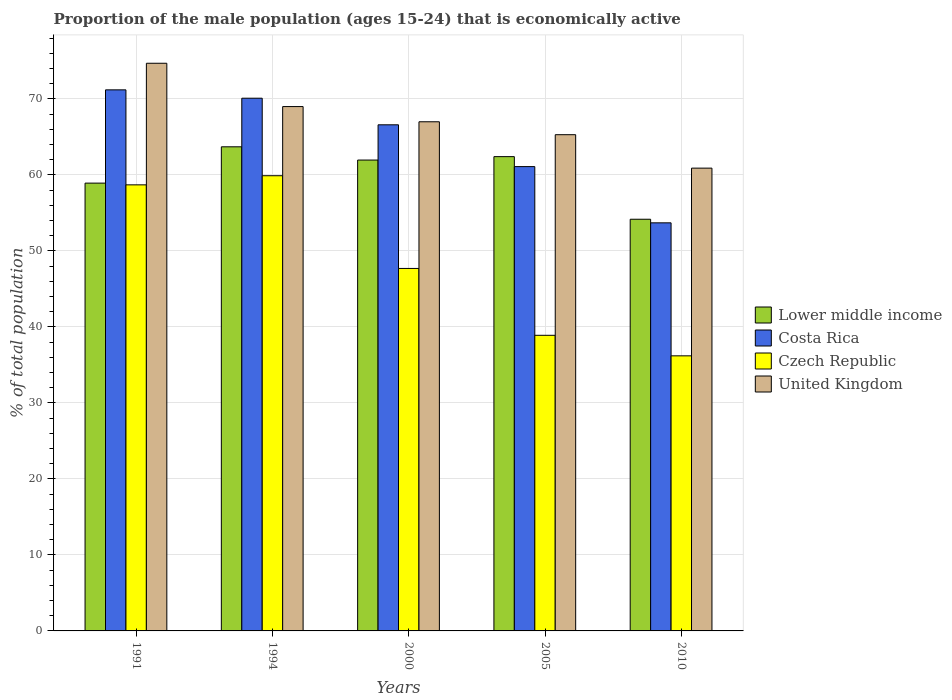How many different coloured bars are there?
Provide a short and direct response. 4. How many groups of bars are there?
Make the answer very short. 5. Are the number of bars per tick equal to the number of legend labels?
Offer a very short reply. Yes. Are the number of bars on each tick of the X-axis equal?
Your answer should be very brief. Yes. How many bars are there on the 3rd tick from the left?
Provide a short and direct response. 4. What is the label of the 4th group of bars from the left?
Ensure brevity in your answer.  2005. In how many cases, is the number of bars for a given year not equal to the number of legend labels?
Make the answer very short. 0. What is the proportion of the male population that is economically active in Lower middle income in 1991?
Your answer should be very brief. 58.93. Across all years, what is the maximum proportion of the male population that is economically active in Lower middle income?
Keep it short and to the point. 63.71. Across all years, what is the minimum proportion of the male population that is economically active in Costa Rica?
Offer a terse response. 53.7. In which year was the proportion of the male population that is economically active in Lower middle income maximum?
Ensure brevity in your answer.  1994. What is the total proportion of the male population that is economically active in Czech Republic in the graph?
Offer a very short reply. 241.4. What is the difference between the proportion of the male population that is economically active in Lower middle income in 1994 and that in 2005?
Give a very brief answer. 1.29. What is the difference between the proportion of the male population that is economically active in Lower middle income in 2005 and the proportion of the male population that is economically active in Costa Rica in 1991?
Keep it short and to the point. -8.79. What is the average proportion of the male population that is economically active in Czech Republic per year?
Give a very brief answer. 48.28. In the year 2005, what is the difference between the proportion of the male population that is economically active in Lower middle income and proportion of the male population that is economically active in United Kingdom?
Give a very brief answer. -2.89. In how many years, is the proportion of the male population that is economically active in United Kingdom greater than 54 %?
Provide a short and direct response. 5. What is the ratio of the proportion of the male population that is economically active in Costa Rica in 1991 to that in 2010?
Your answer should be very brief. 1.33. What is the difference between the highest and the second highest proportion of the male population that is economically active in Czech Republic?
Your answer should be compact. 1.2. What is the difference between the highest and the lowest proportion of the male population that is economically active in Costa Rica?
Give a very brief answer. 17.5. In how many years, is the proportion of the male population that is economically active in Czech Republic greater than the average proportion of the male population that is economically active in Czech Republic taken over all years?
Offer a terse response. 2. Is it the case that in every year, the sum of the proportion of the male population that is economically active in Costa Rica and proportion of the male population that is economically active in Lower middle income is greater than the sum of proportion of the male population that is economically active in United Kingdom and proportion of the male population that is economically active in Czech Republic?
Ensure brevity in your answer.  No. What does the 2nd bar from the left in 2000 represents?
Provide a short and direct response. Costa Rica. What does the 1st bar from the right in 2000 represents?
Your response must be concise. United Kingdom. How many bars are there?
Provide a short and direct response. 20. Are all the bars in the graph horizontal?
Offer a very short reply. No. How many years are there in the graph?
Keep it short and to the point. 5. What is the difference between two consecutive major ticks on the Y-axis?
Your answer should be compact. 10. Does the graph contain grids?
Your answer should be compact. Yes. How are the legend labels stacked?
Provide a succinct answer. Vertical. What is the title of the graph?
Provide a succinct answer. Proportion of the male population (ages 15-24) that is economically active. What is the label or title of the X-axis?
Make the answer very short. Years. What is the label or title of the Y-axis?
Provide a succinct answer. % of total population. What is the % of total population of Lower middle income in 1991?
Offer a terse response. 58.93. What is the % of total population in Costa Rica in 1991?
Keep it short and to the point. 71.2. What is the % of total population in Czech Republic in 1991?
Keep it short and to the point. 58.7. What is the % of total population in United Kingdom in 1991?
Offer a terse response. 74.7. What is the % of total population in Lower middle income in 1994?
Offer a very short reply. 63.71. What is the % of total population in Costa Rica in 1994?
Make the answer very short. 70.1. What is the % of total population in Czech Republic in 1994?
Offer a terse response. 59.9. What is the % of total population in United Kingdom in 1994?
Offer a very short reply. 69. What is the % of total population in Lower middle income in 2000?
Make the answer very short. 61.96. What is the % of total population in Costa Rica in 2000?
Offer a very short reply. 66.6. What is the % of total population in Czech Republic in 2000?
Provide a short and direct response. 47.7. What is the % of total population in Lower middle income in 2005?
Offer a terse response. 62.41. What is the % of total population of Costa Rica in 2005?
Your response must be concise. 61.1. What is the % of total population in Czech Republic in 2005?
Your answer should be very brief. 38.9. What is the % of total population in United Kingdom in 2005?
Make the answer very short. 65.3. What is the % of total population of Lower middle income in 2010?
Keep it short and to the point. 54.17. What is the % of total population in Costa Rica in 2010?
Offer a terse response. 53.7. What is the % of total population in Czech Republic in 2010?
Your answer should be compact. 36.2. What is the % of total population of United Kingdom in 2010?
Keep it short and to the point. 60.9. Across all years, what is the maximum % of total population in Lower middle income?
Provide a short and direct response. 63.71. Across all years, what is the maximum % of total population in Costa Rica?
Your response must be concise. 71.2. Across all years, what is the maximum % of total population of Czech Republic?
Provide a succinct answer. 59.9. Across all years, what is the maximum % of total population of United Kingdom?
Your answer should be compact. 74.7. Across all years, what is the minimum % of total population of Lower middle income?
Give a very brief answer. 54.17. Across all years, what is the minimum % of total population in Costa Rica?
Your answer should be very brief. 53.7. Across all years, what is the minimum % of total population in Czech Republic?
Give a very brief answer. 36.2. Across all years, what is the minimum % of total population in United Kingdom?
Your response must be concise. 60.9. What is the total % of total population in Lower middle income in the graph?
Your answer should be very brief. 301.18. What is the total % of total population in Costa Rica in the graph?
Give a very brief answer. 322.7. What is the total % of total population in Czech Republic in the graph?
Offer a very short reply. 241.4. What is the total % of total population of United Kingdom in the graph?
Your answer should be compact. 336.9. What is the difference between the % of total population of Lower middle income in 1991 and that in 1994?
Provide a succinct answer. -4.78. What is the difference between the % of total population in Costa Rica in 1991 and that in 1994?
Ensure brevity in your answer.  1.1. What is the difference between the % of total population of Czech Republic in 1991 and that in 1994?
Make the answer very short. -1.2. What is the difference between the % of total population in United Kingdom in 1991 and that in 1994?
Your answer should be very brief. 5.7. What is the difference between the % of total population in Lower middle income in 1991 and that in 2000?
Give a very brief answer. -3.04. What is the difference between the % of total population in Costa Rica in 1991 and that in 2000?
Offer a terse response. 4.6. What is the difference between the % of total population of Czech Republic in 1991 and that in 2000?
Make the answer very short. 11. What is the difference between the % of total population in United Kingdom in 1991 and that in 2000?
Your answer should be compact. 7.7. What is the difference between the % of total population of Lower middle income in 1991 and that in 2005?
Provide a succinct answer. -3.49. What is the difference between the % of total population in Czech Republic in 1991 and that in 2005?
Offer a terse response. 19.8. What is the difference between the % of total population in Lower middle income in 1991 and that in 2010?
Your answer should be very brief. 4.75. What is the difference between the % of total population of Czech Republic in 1991 and that in 2010?
Provide a short and direct response. 22.5. What is the difference between the % of total population in United Kingdom in 1991 and that in 2010?
Provide a succinct answer. 13.8. What is the difference between the % of total population of Lower middle income in 1994 and that in 2000?
Your response must be concise. 1.74. What is the difference between the % of total population of United Kingdom in 1994 and that in 2000?
Make the answer very short. 2. What is the difference between the % of total population of Lower middle income in 1994 and that in 2005?
Offer a very short reply. 1.29. What is the difference between the % of total population of Lower middle income in 1994 and that in 2010?
Ensure brevity in your answer.  9.53. What is the difference between the % of total population of Costa Rica in 1994 and that in 2010?
Your response must be concise. 16.4. What is the difference between the % of total population of Czech Republic in 1994 and that in 2010?
Offer a terse response. 23.7. What is the difference between the % of total population of United Kingdom in 1994 and that in 2010?
Your answer should be very brief. 8.1. What is the difference between the % of total population in Lower middle income in 2000 and that in 2005?
Give a very brief answer. -0.45. What is the difference between the % of total population in United Kingdom in 2000 and that in 2005?
Offer a terse response. 1.7. What is the difference between the % of total population of Lower middle income in 2000 and that in 2010?
Offer a terse response. 7.79. What is the difference between the % of total population in Costa Rica in 2000 and that in 2010?
Make the answer very short. 12.9. What is the difference between the % of total population of Lower middle income in 2005 and that in 2010?
Provide a succinct answer. 8.24. What is the difference between the % of total population of Costa Rica in 2005 and that in 2010?
Make the answer very short. 7.4. What is the difference between the % of total population in Czech Republic in 2005 and that in 2010?
Provide a short and direct response. 2.7. What is the difference between the % of total population of United Kingdom in 2005 and that in 2010?
Ensure brevity in your answer.  4.4. What is the difference between the % of total population in Lower middle income in 1991 and the % of total population in Costa Rica in 1994?
Ensure brevity in your answer.  -11.17. What is the difference between the % of total population in Lower middle income in 1991 and the % of total population in Czech Republic in 1994?
Offer a very short reply. -0.97. What is the difference between the % of total population of Lower middle income in 1991 and the % of total population of United Kingdom in 1994?
Make the answer very short. -10.07. What is the difference between the % of total population of Costa Rica in 1991 and the % of total population of Czech Republic in 1994?
Offer a very short reply. 11.3. What is the difference between the % of total population in Costa Rica in 1991 and the % of total population in United Kingdom in 1994?
Give a very brief answer. 2.2. What is the difference between the % of total population of Czech Republic in 1991 and the % of total population of United Kingdom in 1994?
Provide a short and direct response. -10.3. What is the difference between the % of total population of Lower middle income in 1991 and the % of total population of Costa Rica in 2000?
Keep it short and to the point. -7.67. What is the difference between the % of total population in Lower middle income in 1991 and the % of total population in Czech Republic in 2000?
Ensure brevity in your answer.  11.23. What is the difference between the % of total population of Lower middle income in 1991 and the % of total population of United Kingdom in 2000?
Offer a terse response. -8.07. What is the difference between the % of total population in Costa Rica in 1991 and the % of total population in Czech Republic in 2000?
Provide a short and direct response. 23.5. What is the difference between the % of total population of Costa Rica in 1991 and the % of total population of United Kingdom in 2000?
Make the answer very short. 4.2. What is the difference between the % of total population of Lower middle income in 1991 and the % of total population of Costa Rica in 2005?
Provide a short and direct response. -2.17. What is the difference between the % of total population in Lower middle income in 1991 and the % of total population in Czech Republic in 2005?
Give a very brief answer. 20.03. What is the difference between the % of total population in Lower middle income in 1991 and the % of total population in United Kingdom in 2005?
Provide a short and direct response. -6.37. What is the difference between the % of total population of Costa Rica in 1991 and the % of total population of Czech Republic in 2005?
Provide a succinct answer. 32.3. What is the difference between the % of total population in Czech Republic in 1991 and the % of total population in United Kingdom in 2005?
Keep it short and to the point. -6.6. What is the difference between the % of total population of Lower middle income in 1991 and the % of total population of Costa Rica in 2010?
Offer a very short reply. 5.23. What is the difference between the % of total population of Lower middle income in 1991 and the % of total population of Czech Republic in 2010?
Provide a succinct answer. 22.73. What is the difference between the % of total population of Lower middle income in 1991 and the % of total population of United Kingdom in 2010?
Keep it short and to the point. -1.97. What is the difference between the % of total population of Lower middle income in 1994 and the % of total population of Costa Rica in 2000?
Your answer should be compact. -2.89. What is the difference between the % of total population in Lower middle income in 1994 and the % of total population in Czech Republic in 2000?
Keep it short and to the point. 16.01. What is the difference between the % of total population in Lower middle income in 1994 and the % of total population in United Kingdom in 2000?
Offer a terse response. -3.29. What is the difference between the % of total population of Costa Rica in 1994 and the % of total population of Czech Republic in 2000?
Offer a terse response. 22.4. What is the difference between the % of total population of Czech Republic in 1994 and the % of total population of United Kingdom in 2000?
Your response must be concise. -7.1. What is the difference between the % of total population of Lower middle income in 1994 and the % of total population of Costa Rica in 2005?
Provide a short and direct response. 2.61. What is the difference between the % of total population of Lower middle income in 1994 and the % of total population of Czech Republic in 2005?
Give a very brief answer. 24.81. What is the difference between the % of total population in Lower middle income in 1994 and the % of total population in United Kingdom in 2005?
Give a very brief answer. -1.59. What is the difference between the % of total population in Costa Rica in 1994 and the % of total population in Czech Republic in 2005?
Your response must be concise. 31.2. What is the difference between the % of total population of Lower middle income in 1994 and the % of total population of Costa Rica in 2010?
Offer a terse response. 10.01. What is the difference between the % of total population in Lower middle income in 1994 and the % of total population in Czech Republic in 2010?
Offer a terse response. 27.51. What is the difference between the % of total population of Lower middle income in 1994 and the % of total population of United Kingdom in 2010?
Provide a succinct answer. 2.81. What is the difference between the % of total population of Costa Rica in 1994 and the % of total population of Czech Republic in 2010?
Give a very brief answer. 33.9. What is the difference between the % of total population in Costa Rica in 1994 and the % of total population in United Kingdom in 2010?
Ensure brevity in your answer.  9.2. What is the difference between the % of total population of Czech Republic in 1994 and the % of total population of United Kingdom in 2010?
Your response must be concise. -1. What is the difference between the % of total population of Lower middle income in 2000 and the % of total population of Costa Rica in 2005?
Your response must be concise. 0.86. What is the difference between the % of total population of Lower middle income in 2000 and the % of total population of Czech Republic in 2005?
Make the answer very short. 23.06. What is the difference between the % of total population in Lower middle income in 2000 and the % of total population in United Kingdom in 2005?
Ensure brevity in your answer.  -3.34. What is the difference between the % of total population of Costa Rica in 2000 and the % of total population of Czech Republic in 2005?
Give a very brief answer. 27.7. What is the difference between the % of total population of Czech Republic in 2000 and the % of total population of United Kingdom in 2005?
Your answer should be compact. -17.6. What is the difference between the % of total population in Lower middle income in 2000 and the % of total population in Costa Rica in 2010?
Your answer should be compact. 8.26. What is the difference between the % of total population of Lower middle income in 2000 and the % of total population of Czech Republic in 2010?
Provide a succinct answer. 25.76. What is the difference between the % of total population in Lower middle income in 2000 and the % of total population in United Kingdom in 2010?
Keep it short and to the point. 1.06. What is the difference between the % of total population in Costa Rica in 2000 and the % of total population in Czech Republic in 2010?
Make the answer very short. 30.4. What is the difference between the % of total population in Costa Rica in 2000 and the % of total population in United Kingdom in 2010?
Offer a terse response. 5.7. What is the difference between the % of total population in Lower middle income in 2005 and the % of total population in Costa Rica in 2010?
Your answer should be compact. 8.71. What is the difference between the % of total population in Lower middle income in 2005 and the % of total population in Czech Republic in 2010?
Ensure brevity in your answer.  26.21. What is the difference between the % of total population in Lower middle income in 2005 and the % of total population in United Kingdom in 2010?
Your response must be concise. 1.51. What is the difference between the % of total population in Costa Rica in 2005 and the % of total population in Czech Republic in 2010?
Keep it short and to the point. 24.9. What is the difference between the % of total population in Costa Rica in 2005 and the % of total population in United Kingdom in 2010?
Ensure brevity in your answer.  0.2. What is the average % of total population of Lower middle income per year?
Ensure brevity in your answer.  60.24. What is the average % of total population of Costa Rica per year?
Offer a terse response. 64.54. What is the average % of total population in Czech Republic per year?
Offer a very short reply. 48.28. What is the average % of total population of United Kingdom per year?
Give a very brief answer. 67.38. In the year 1991, what is the difference between the % of total population in Lower middle income and % of total population in Costa Rica?
Provide a short and direct response. -12.27. In the year 1991, what is the difference between the % of total population in Lower middle income and % of total population in Czech Republic?
Ensure brevity in your answer.  0.23. In the year 1991, what is the difference between the % of total population in Lower middle income and % of total population in United Kingdom?
Offer a very short reply. -15.77. In the year 1991, what is the difference between the % of total population in Czech Republic and % of total population in United Kingdom?
Offer a terse response. -16. In the year 1994, what is the difference between the % of total population in Lower middle income and % of total population in Costa Rica?
Your answer should be compact. -6.39. In the year 1994, what is the difference between the % of total population in Lower middle income and % of total population in Czech Republic?
Give a very brief answer. 3.81. In the year 1994, what is the difference between the % of total population of Lower middle income and % of total population of United Kingdom?
Give a very brief answer. -5.29. In the year 1994, what is the difference between the % of total population of Costa Rica and % of total population of Czech Republic?
Your response must be concise. 10.2. In the year 1994, what is the difference between the % of total population in Czech Republic and % of total population in United Kingdom?
Make the answer very short. -9.1. In the year 2000, what is the difference between the % of total population of Lower middle income and % of total population of Costa Rica?
Your answer should be very brief. -4.64. In the year 2000, what is the difference between the % of total population in Lower middle income and % of total population in Czech Republic?
Offer a terse response. 14.26. In the year 2000, what is the difference between the % of total population of Lower middle income and % of total population of United Kingdom?
Offer a very short reply. -5.04. In the year 2000, what is the difference between the % of total population in Costa Rica and % of total population in United Kingdom?
Provide a short and direct response. -0.4. In the year 2000, what is the difference between the % of total population in Czech Republic and % of total population in United Kingdom?
Provide a succinct answer. -19.3. In the year 2005, what is the difference between the % of total population in Lower middle income and % of total population in Costa Rica?
Make the answer very short. 1.31. In the year 2005, what is the difference between the % of total population of Lower middle income and % of total population of Czech Republic?
Make the answer very short. 23.51. In the year 2005, what is the difference between the % of total population in Lower middle income and % of total population in United Kingdom?
Your response must be concise. -2.89. In the year 2005, what is the difference between the % of total population in Costa Rica and % of total population in Czech Republic?
Give a very brief answer. 22.2. In the year 2005, what is the difference between the % of total population in Czech Republic and % of total population in United Kingdom?
Provide a succinct answer. -26.4. In the year 2010, what is the difference between the % of total population in Lower middle income and % of total population in Costa Rica?
Offer a terse response. 0.47. In the year 2010, what is the difference between the % of total population in Lower middle income and % of total population in Czech Republic?
Your answer should be compact. 17.97. In the year 2010, what is the difference between the % of total population in Lower middle income and % of total population in United Kingdom?
Keep it short and to the point. -6.73. In the year 2010, what is the difference between the % of total population of Costa Rica and % of total population of Czech Republic?
Your answer should be very brief. 17.5. In the year 2010, what is the difference between the % of total population of Costa Rica and % of total population of United Kingdom?
Provide a succinct answer. -7.2. In the year 2010, what is the difference between the % of total population of Czech Republic and % of total population of United Kingdom?
Your answer should be very brief. -24.7. What is the ratio of the % of total population in Lower middle income in 1991 to that in 1994?
Provide a succinct answer. 0.93. What is the ratio of the % of total population in Costa Rica in 1991 to that in 1994?
Give a very brief answer. 1.02. What is the ratio of the % of total population in Czech Republic in 1991 to that in 1994?
Keep it short and to the point. 0.98. What is the ratio of the % of total population in United Kingdom in 1991 to that in 1994?
Ensure brevity in your answer.  1.08. What is the ratio of the % of total population of Lower middle income in 1991 to that in 2000?
Your answer should be compact. 0.95. What is the ratio of the % of total population of Costa Rica in 1991 to that in 2000?
Your response must be concise. 1.07. What is the ratio of the % of total population of Czech Republic in 1991 to that in 2000?
Provide a succinct answer. 1.23. What is the ratio of the % of total population in United Kingdom in 1991 to that in 2000?
Provide a succinct answer. 1.11. What is the ratio of the % of total population of Lower middle income in 1991 to that in 2005?
Offer a very short reply. 0.94. What is the ratio of the % of total population in Costa Rica in 1991 to that in 2005?
Keep it short and to the point. 1.17. What is the ratio of the % of total population in Czech Republic in 1991 to that in 2005?
Offer a very short reply. 1.51. What is the ratio of the % of total population in United Kingdom in 1991 to that in 2005?
Offer a terse response. 1.14. What is the ratio of the % of total population in Lower middle income in 1991 to that in 2010?
Your answer should be very brief. 1.09. What is the ratio of the % of total population in Costa Rica in 1991 to that in 2010?
Your response must be concise. 1.33. What is the ratio of the % of total population in Czech Republic in 1991 to that in 2010?
Give a very brief answer. 1.62. What is the ratio of the % of total population in United Kingdom in 1991 to that in 2010?
Give a very brief answer. 1.23. What is the ratio of the % of total population of Lower middle income in 1994 to that in 2000?
Ensure brevity in your answer.  1.03. What is the ratio of the % of total population of Costa Rica in 1994 to that in 2000?
Provide a short and direct response. 1.05. What is the ratio of the % of total population in Czech Republic in 1994 to that in 2000?
Provide a short and direct response. 1.26. What is the ratio of the % of total population in United Kingdom in 1994 to that in 2000?
Provide a succinct answer. 1.03. What is the ratio of the % of total population in Lower middle income in 1994 to that in 2005?
Offer a terse response. 1.02. What is the ratio of the % of total population in Costa Rica in 1994 to that in 2005?
Provide a succinct answer. 1.15. What is the ratio of the % of total population in Czech Republic in 1994 to that in 2005?
Ensure brevity in your answer.  1.54. What is the ratio of the % of total population of United Kingdom in 1994 to that in 2005?
Provide a short and direct response. 1.06. What is the ratio of the % of total population in Lower middle income in 1994 to that in 2010?
Your answer should be compact. 1.18. What is the ratio of the % of total population of Costa Rica in 1994 to that in 2010?
Your answer should be very brief. 1.31. What is the ratio of the % of total population of Czech Republic in 1994 to that in 2010?
Your response must be concise. 1.65. What is the ratio of the % of total population of United Kingdom in 1994 to that in 2010?
Provide a succinct answer. 1.13. What is the ratio of the % of total population of Lower middle income in 2000 to that in 2005?
Your answer should be compact. 0.99. What is the ratio of the % of total population in Costa Rica in 2000 to that in 2005?
Offer a terse response. 1.09. What is the ratio of the % of total population of Czech Republic in 2000 to that in 2005?
Offer a very short reply. 1.23. What is the ratio of the % of total population in Lower middle income in 2000 to that in 2010?
Provide a succinct answer. 1.14. What is the ratio of the % of total population in Costa Rica in 2000 to that in 2010?
Your response must be concise. 1.24. What is the ratio of the % of total population in Czech Republic in 2000 to that in 2010?
Provide a short and direct response. 1.32. What is the ratio of the % of total population in United Kingdom in 2000 to that in 2010?
Make the answer very short. 1.1. What is the ratio of the % of total population of Lower middle income in 2005 to that in 2010?
Provide a short and direct response. 1.15. What is the ratio of the % of total population of Costa Rica in 2005 to that in 2010?
Your answer should be compact. 1.14. What is the ratio of the % of total population of Czech Republic in 2005 to that in 2010?
Keep it short and to the point. 1.07. What is the ratio of the % of total population of United Kingdom in 2005 to that in 2010?
Make the answer very short. 1.07. What is the difference between the highest and the second highest % of total population of Lower middle income?
Your response must be concise. 1.29. What is the difference between the highest and the second highest % of total population in Czech Republic?
Make the answer very short. 1.2. What is the difference between the highest and the lowest % of total population of Lower middle income?
Your answer should be compact. 9.53. What is the difference between the highest and the lowest % of total population of Costa Rica?
Give a very brief answer. 17.5. What is the difference between the highest and the lowest % of total population in Czech Republic?
Provide a short and direct response. 23.7. What is the difference between the highest and the lowest % of total population of United Kingdom?
Your response must be concise. 13.8. 